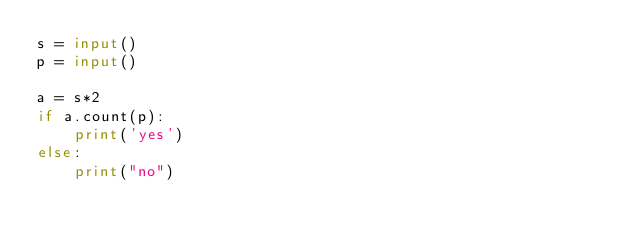<code> <loc_0><loc_0><loc_500><loc_500><_Python_>s = input()
p = input()

a = s*2
if a.count(p):
    print('yes')
else:
    print("no")</code> 